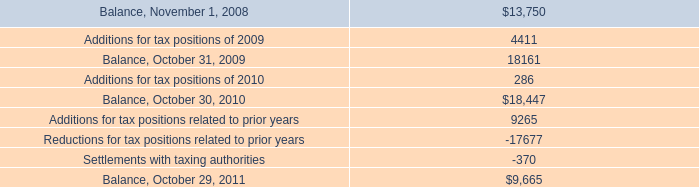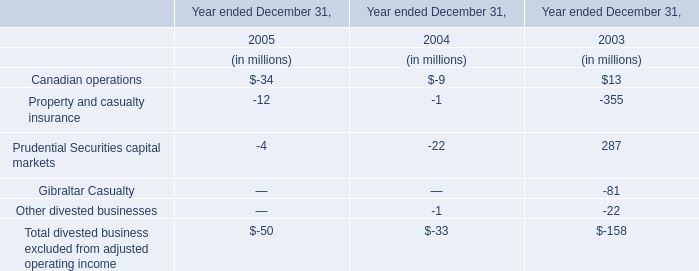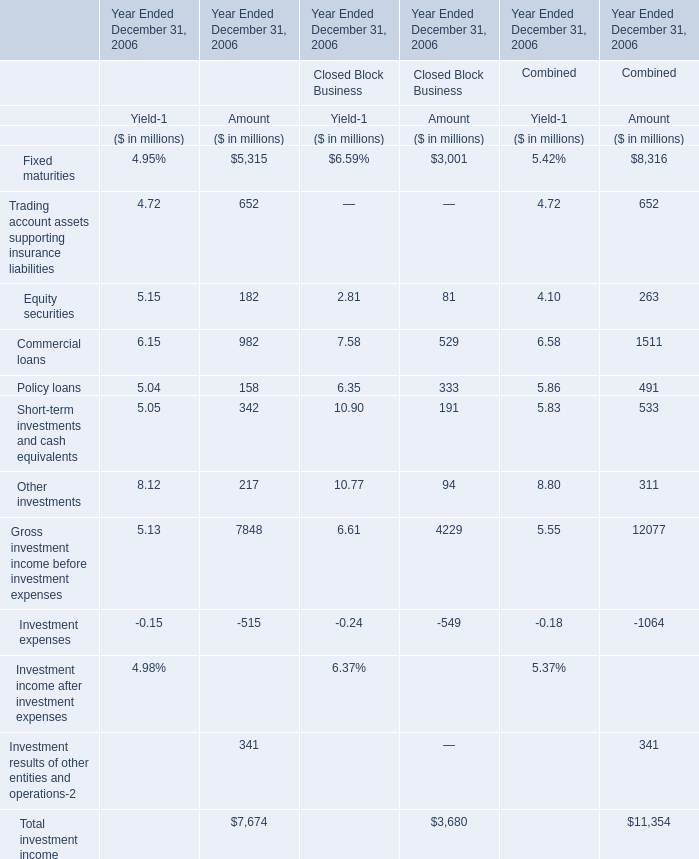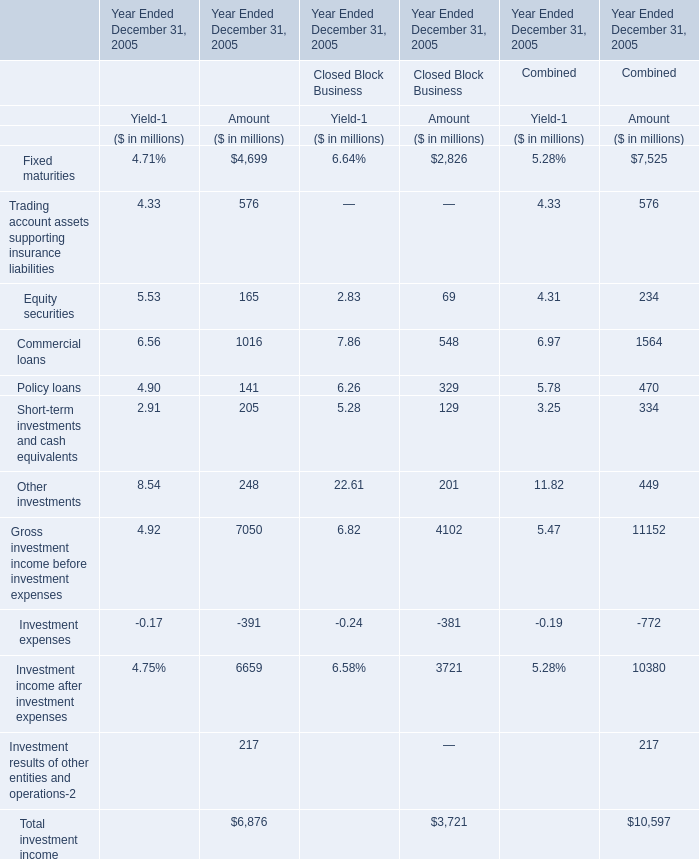What is the total value of Trading account assets supporting insurance liabilities,Equity securities, Commercial loans and Policy loans for Amount in Financial Services Businesses (in million) 
Computations: (((576 + 165) + 1016) + 141)
Answer: 1898.0. 